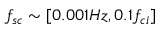Convert formula to latex. <formula><loc_0><loc_0><loc_500><loc_500>f _ { s c } \sim [ 0 . 0 0 1 H z , 0 . 1 f _ { c i } ]</formula> 